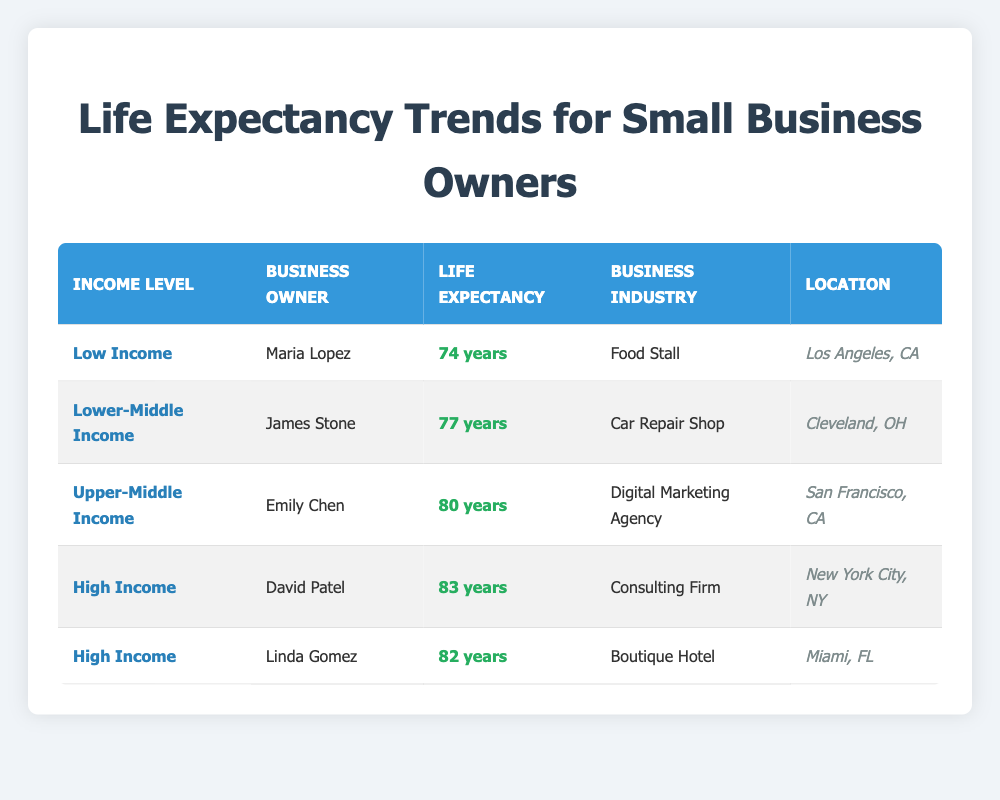What is the life expectancy of Maria Lopez? From the table, Maria Lopez is listed under the "Low Income" category with an average life expectancy of 74 years.
Answer: 74 years Which small business owner has the highest life expectancy? The table shows David Patel has the highest life expectancy at 83 years, categorized under "High Income."
Answer: David Patel What is the difference in life expectancy between James Stone and Linda Gomez? James Stone's life expectancy is 77 years, while Linda Gomez's is 82 years. The difference is 82 - 77 = 5 years.
Answer: 5 years Is Emily Chen a small business owner in the Upper-Middle Income category? According to the table, Emily Chen is indeed categorized as an Upper-Middle Income small business owner.
Answer: Yes What is the average life expectancy for small business owners in the High Income category? The High Income category includes David Patel (83 years) and Linda Gomez (82 years). The average is (83 + 82) / 2 = 82.5 years.
Answer: 82.5 years How many small business owners have a life expectancy below 80 years? The table indicates that both Maria Lopez (74 years) and James Stone (77 years) have a life expectancy below 80 years. Therefore, there are 2 owners.
Answer: 2 owners Which location corresponds to the small business owner with the lowest life expectancy? Maria Lopez has the lowest life expectancy at 74 years, and she is located in Los Angeles, CA.
Answer: Los Angeles, CA What can be inferred about income level and life expectancy from this table? The data indicates that as income level increases from Low Income to High Income, life expectancy also tends to increase, with David Patel (High Income) having 83 years compared to Maria Lopez (Low Income) with 74 years.
Answer: Higher income levels correlate with higher life expectancy 